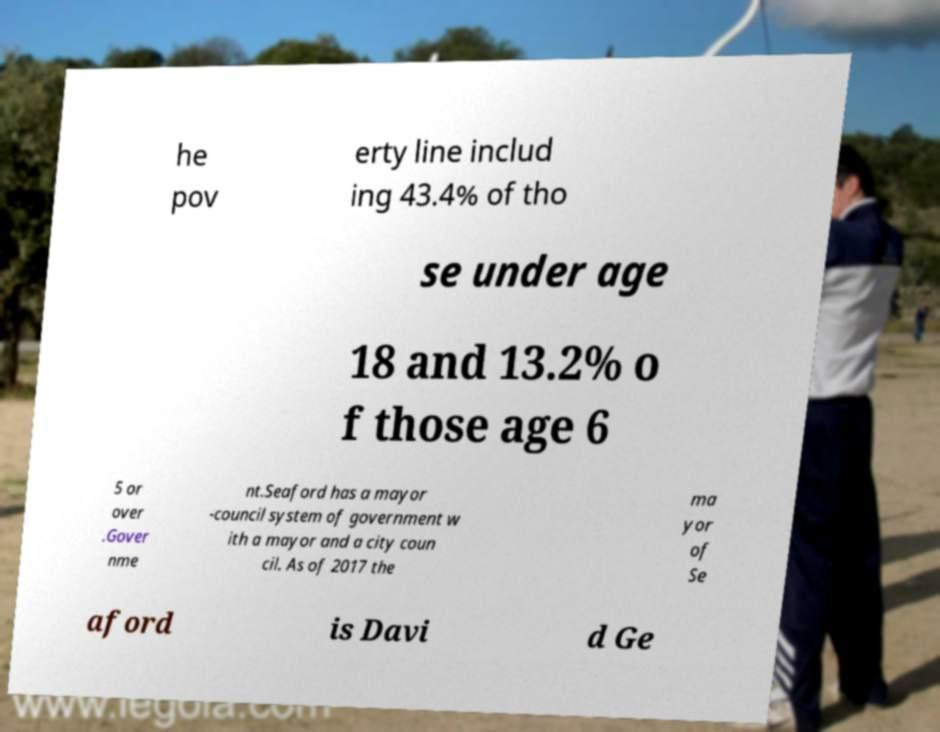I need the written content from this picture converted into text. Can you do that? he pov erty line includ ing 43.4% of tho se under age 18 and 13.2% o f those age 6 5 or over .Gover nme nt.Seaford has a mayor -council system of government w ith a mayor and a city coun cil. As of 2017 the ma yor of Se aford is Davi d Ge 